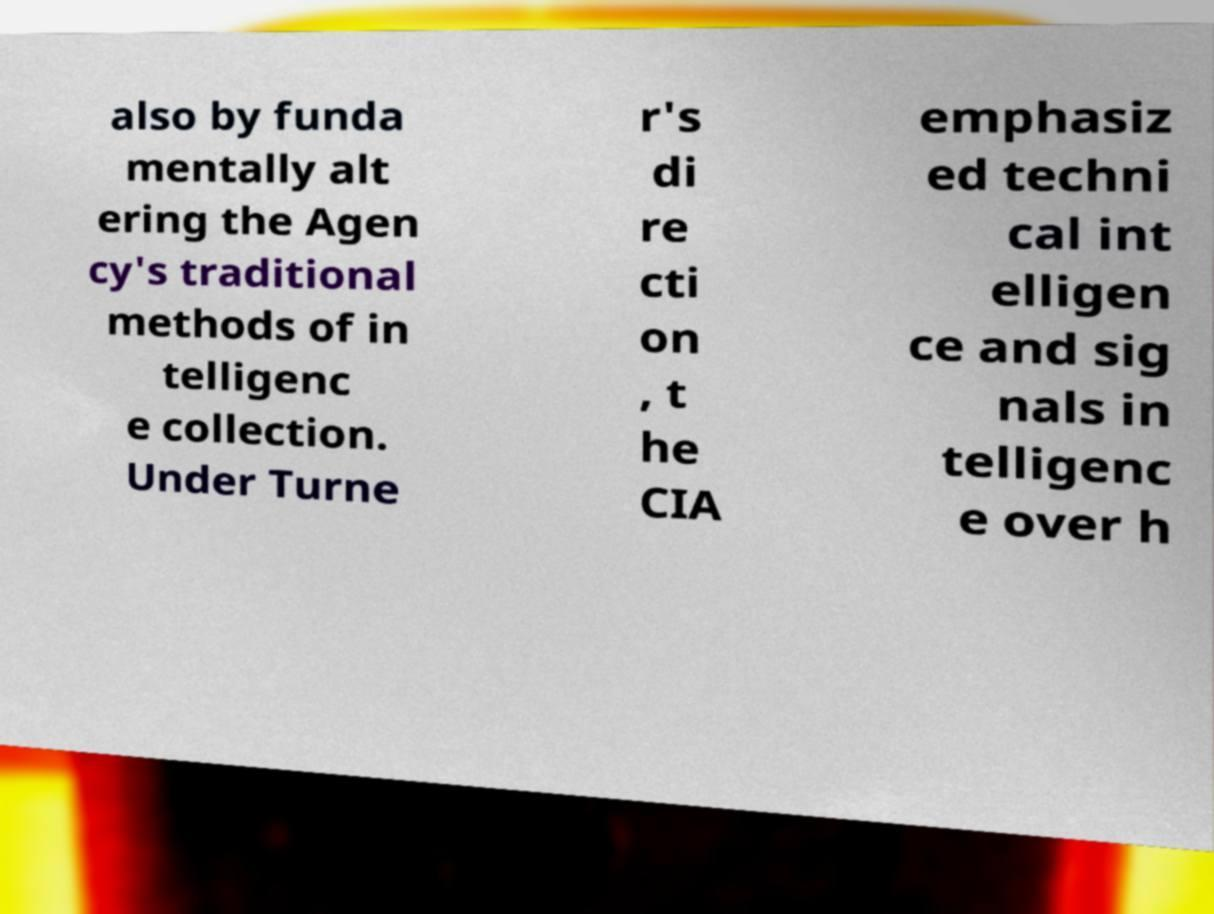Please read and relay the text visible in this image. What does it say? also by funda mentally alt ering the Agen cy's traditional methods of in telligenc e collection. Under Turne r's di re cti on , t he CIA emphasiz ed techni cal int elligen ce and sig nals in telligenc e over h 